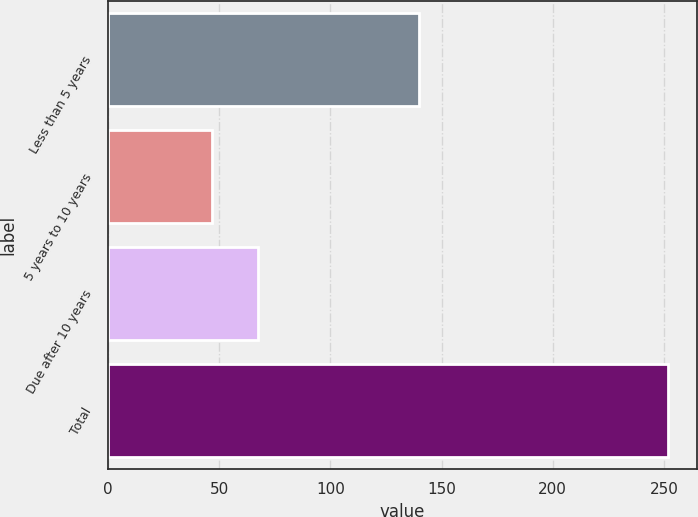<chart> <loc_0><loc_0><loc_500><loc_500><bar_chart><fcel>Less than 5 years<fcel>5 years to 10 years<fcel>Due after 10 years<fcel>Total<nl><fcel>140<fcel>47<fcel>67.5<fcel>252<nl></chart> 